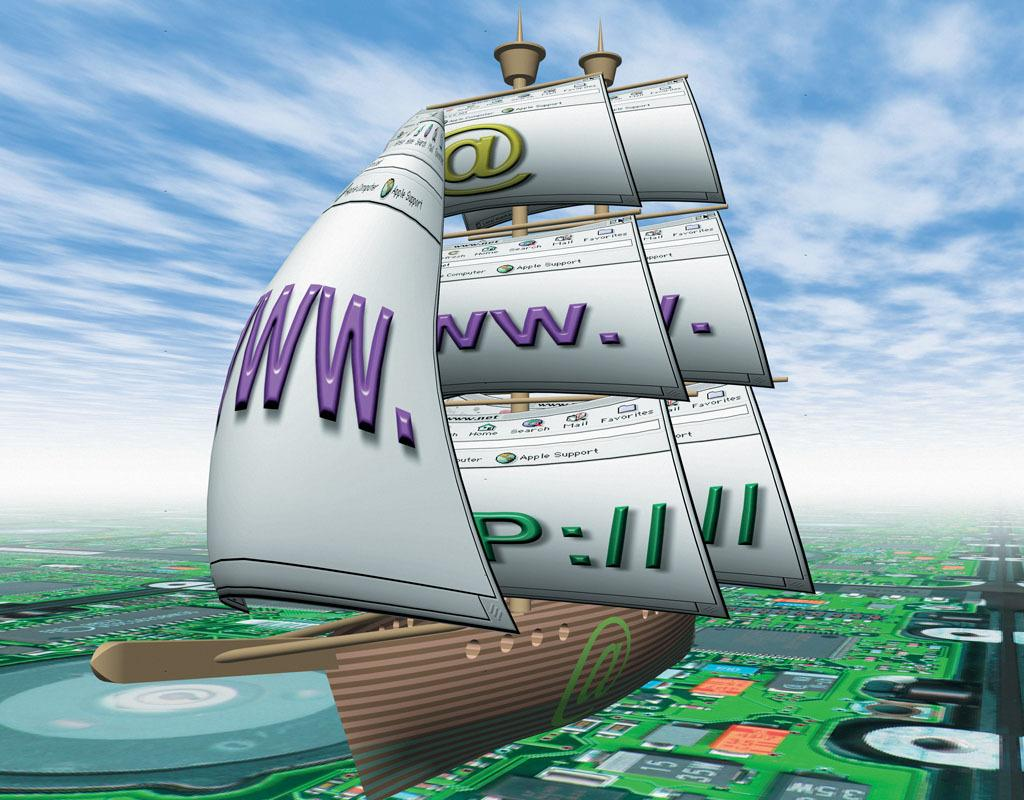What type of picture is the image? The image is an animated picture. What is the main subject in the center of the image? There is a boat in the center of the image. What can be seen in the background of the image? There is a motherboard in the background of the image. What is visible in the sky in the image? The sky is visible in the image, and clouds are present in the sky. What type of ring can be seen on the motherboard in the image? There is no ring present on the motherboard in the image. What is the material of the pump used in the boat in the image? There is no pump visible in the boat in the image. 